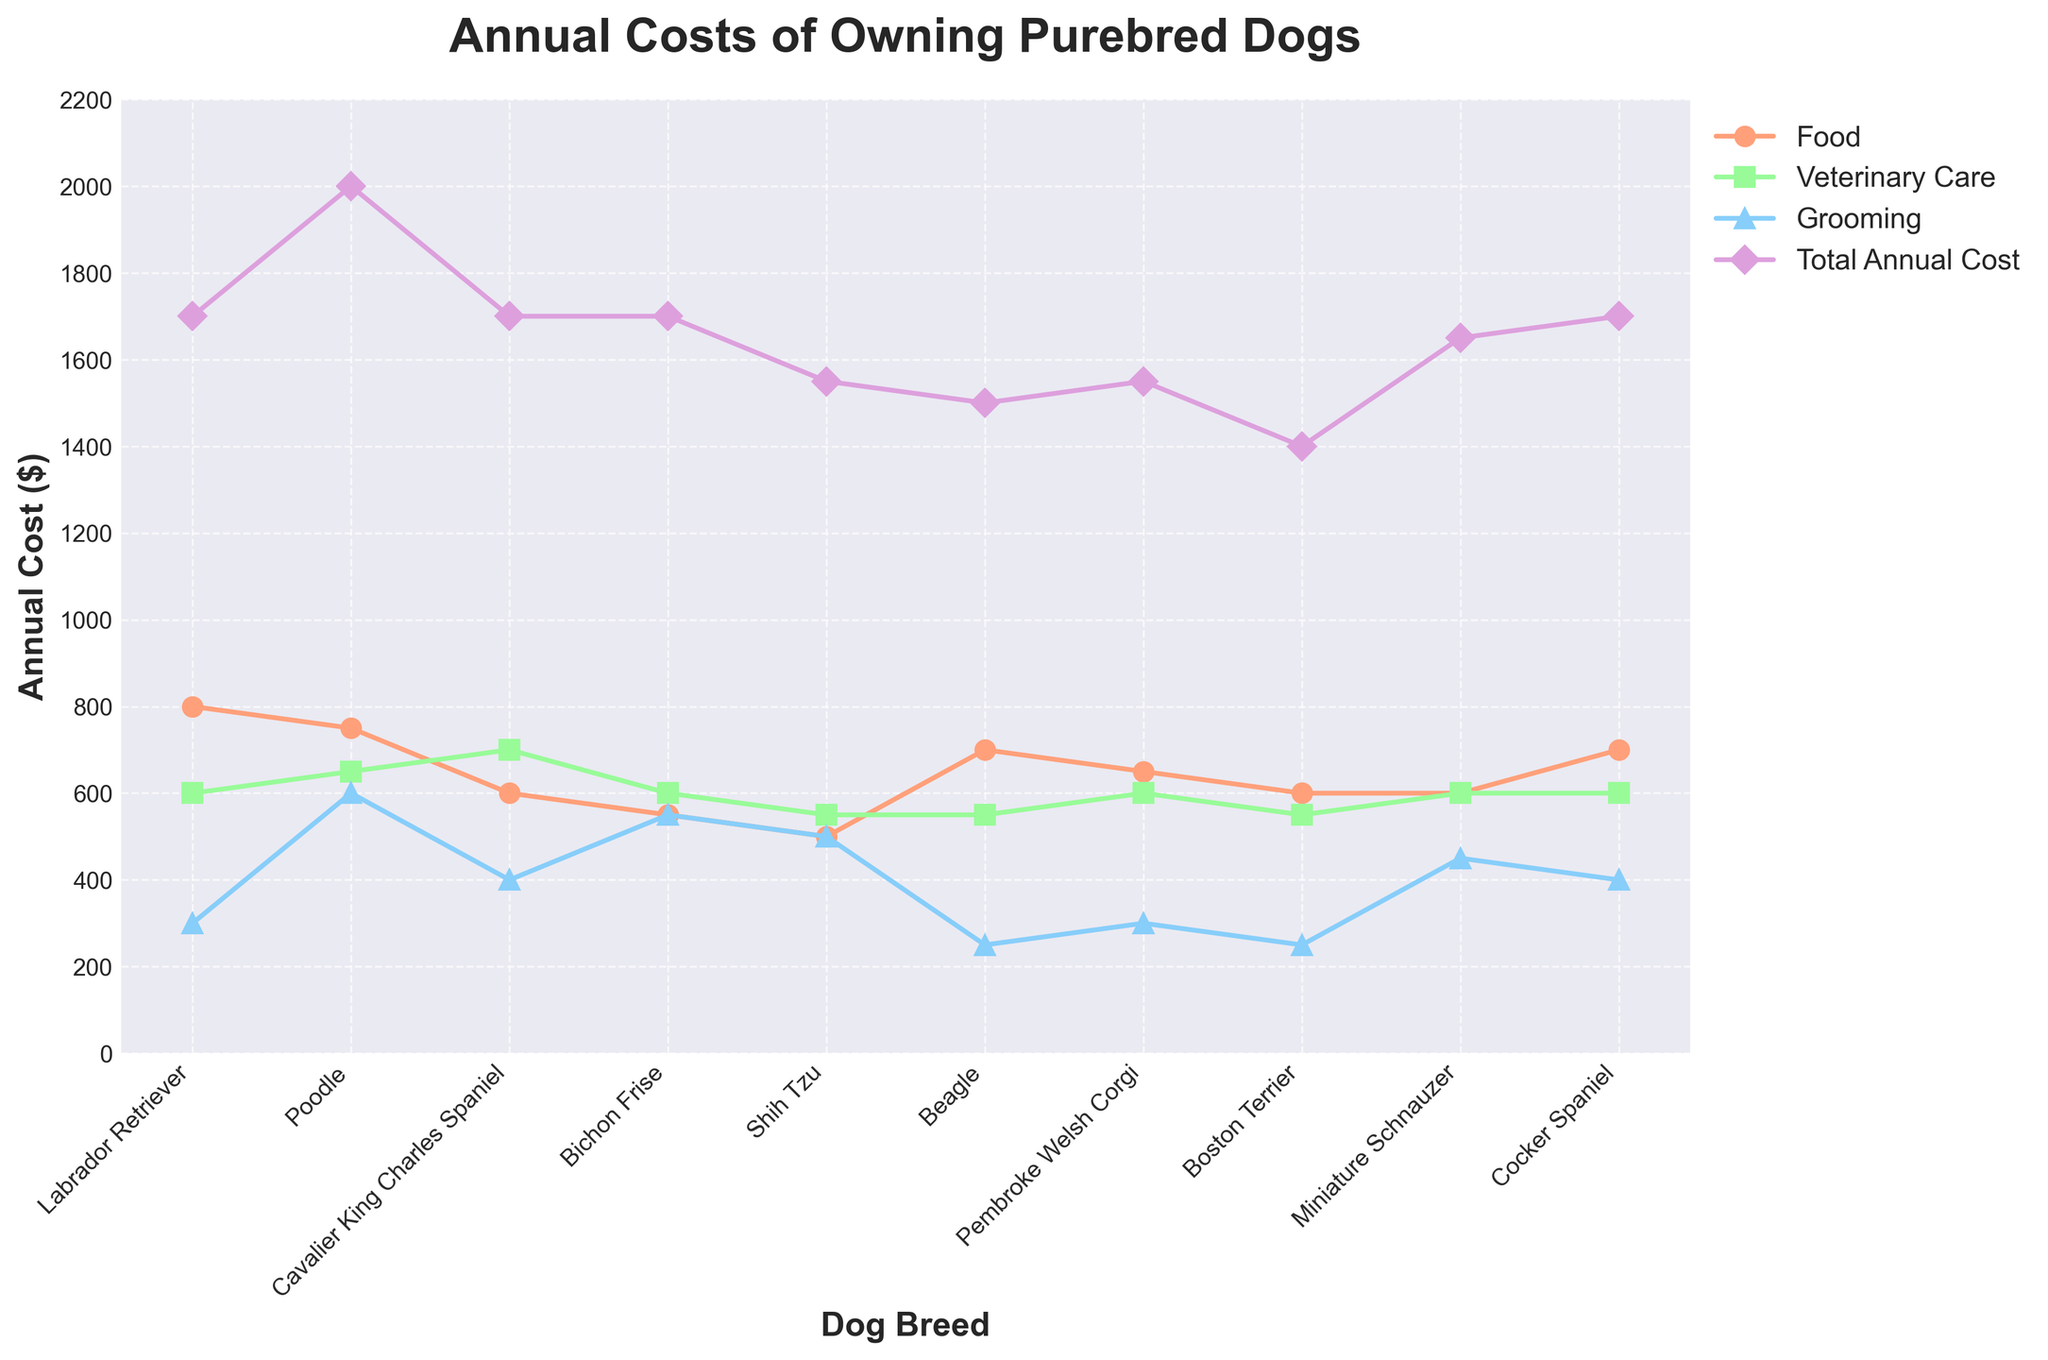Which breed has the highest total annual cost, and what is that cost? The highest total annual cost can be identified by looking at the highest point on the line representing 'Total Annual Cost' in the line chart. The highest point is for the Poodle with a total annual cost of $2000.
Answer: Poodle, $2000 Comparing the food costs, which breed is the cheapest to feed annually? To find the breed with the lowest food cost, look for the lowest point on the line representing 'Food' in the line chart. The Shih Tzu has the lowest annual food cost at $500.
Answer: Shih Tzu, $500 What is the total annual cost difference between the Poodle and the Beagle? To get the difference, subtract the total annual cost of the Beagle from that of the Poodle. The Poodle costs $2000 annually, and the Beagle costs $1500. So, the difference is $2000 - $1500 = $500.
Answer: $500 Which three breeds have the same total annual cost, and what is that cost? Identifying the breeds with overlapping points on the 'Total Annual Cost' line, we see that the Labrador Retriever, Cavalier King Charles Spaniel, Bichon Frise, and Cocker Spaniel all have a total annual cost of $1700.
Answer: Labrador Retriever, Cavalier King Charles Spaniel, Bichon Frise, Cocker Spaniel; $1700 Which breed has the highest grooming expense, and what is that expense? Looking at the highest point on the 'Grooming' line in the chart, the Poodle has the highest grooming expense at $600 annually.
Answer: Poodle, $600 What is the average annual cost of veterinary care for all the breeds combined? Sum all the veterinary care costs and divide by the number of breeds. Sum = (600 + 650 + 700 + 600 + 550 + 550 + 600 + 550 + 600 + 600 = 6000). There are 10 breeds, so the average is 6000/10 = 600.
Answer: $600 Which two categories have the largest difference in costs for the Shih Tzu, and what is that difference? For the Shih Tzu, Food costs $500, Veterinary Care costs $550, and Grooming costs $500. The largest difference is between Veterinary Care and either of the other two categories. Difference = $550 - $500 = $50.
Answer: Veterinary Care and Food/Grooming, $50 Between the Labrador Retriever and Pembroke Welsh Corgi, which breed has higher food costs and by how much? Comparing the food costs for the Labrador Retriever ($800) and Pembroke Welsh Corgi ($650), we see the Labrador Retriever has higher food costs. Difference is $800 - $650 = $150.
Answer: Labrador Retriever, $150 What is the median grooming expense for all the breeds listed? To find the median, list the grooming expenses in ascending order: 250, 250, 300, 300, 400, 400, 450, 500, 500, 550, 600. With 10 data points, the median is the average of the 5th and 6th values: (400 + 400)/2 = $400.
Answer: $400 